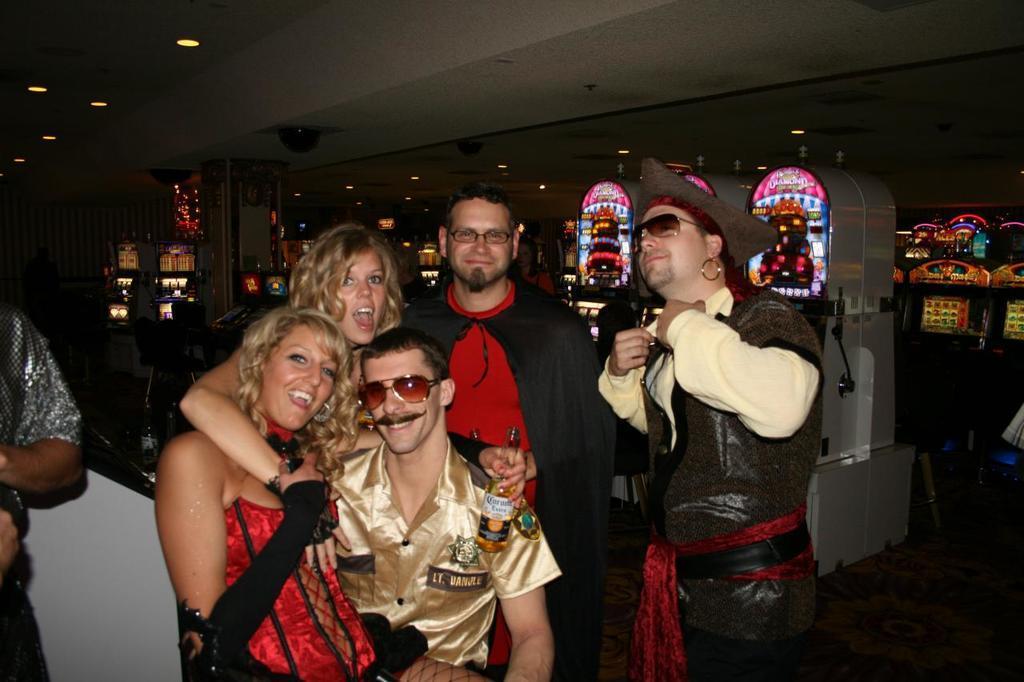In one or two sentences, can you explain what this image depicts? In this image, we can see few people. Few are smiling and holding some objects. Background we can see so many things, chair, wall. Top of the image, there is a roof with lights. 